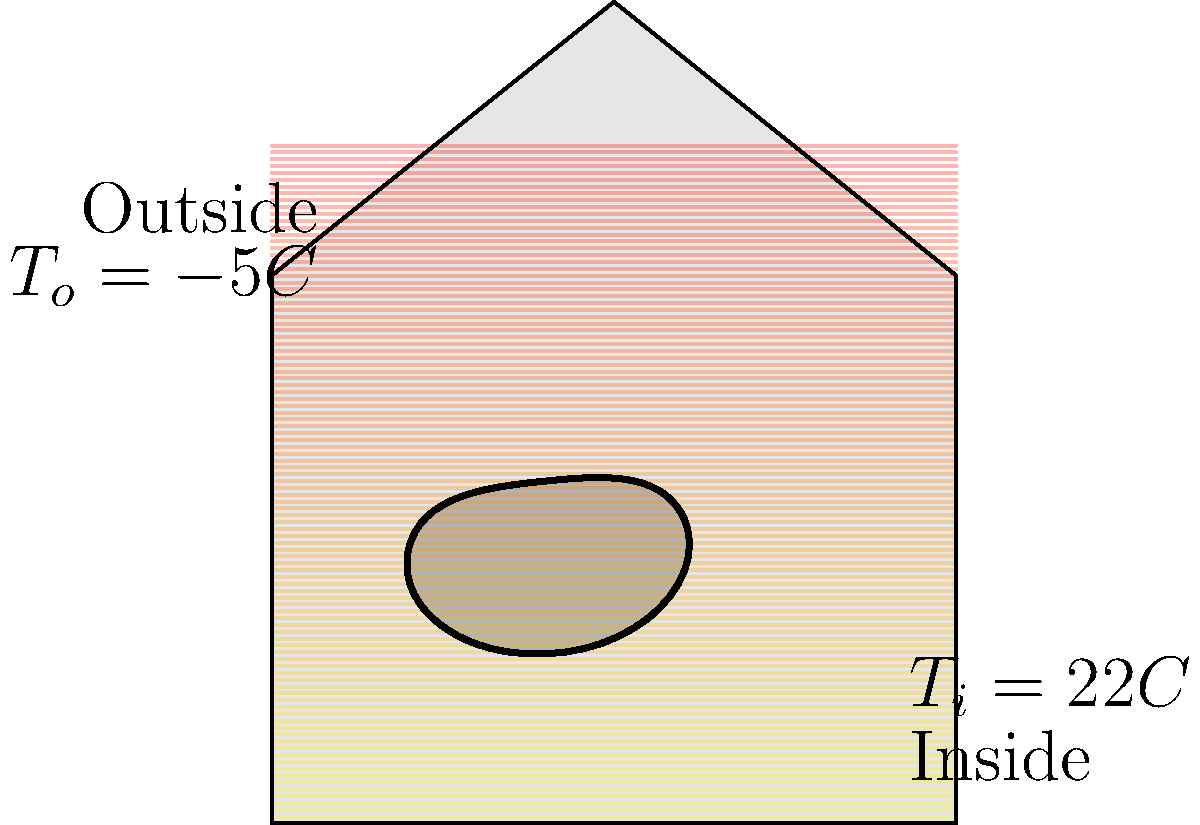An irregularly-shaped window in your unconventional house design is shown in the thermal image above. The window has an average area of 1.2 m² and an average thickness of 6 mm. The thermal conductivity of the window material is 0.78 W/(m·K). If the indoor temperature is 22°C and the outdoor temperature is -5°C, calculate the rate of heat loss through the window in watts. To solve this problem, we'll use Fourier's law of heat conduction:

1) The general form of Fourier's law is:
   $$Q = -kA\frac{dT}{dx}$$
   Where:
   $Q$ = rate of heat transfer (W)
   $k$ = thermal conductivity (W/(m·K))
   $A$ = area (m²)
   $\frac{dT}{dx}$ = temperature gradient (K/m)

2) For our case with constant temperatures on both sides, we can rewrite this as:
   $$Q = kA\frac{T_i - T_o}{L}$$
   Where:
   $T_i$ = indoor temperature (K)
   $T_o$ = outdoor temperature (K)
   $L$ = thickness of the window (m)

3) Let's plug in our values:
   $k = 0.78$ W/(m·K)
   $A = 1.2$ m²
   $T_i = 22°C = 295.15$ K
   $T_o = -5°C = 268.15$ K
   $L = 6$ mm $= 0.006$ m

4) Now we can calculate:
   $$Q = 0.78 \times 1.2 \times \frac{295.15 - 268.15}{0.006}$$

5) Simplifying:
   $$Q = 0.78 \times 1.2 \times \frac{27}{0.006} = 4212$ W

Therefore, the rate of heat loss through the window is approximately 4212 W.
Answer: 4212 W 